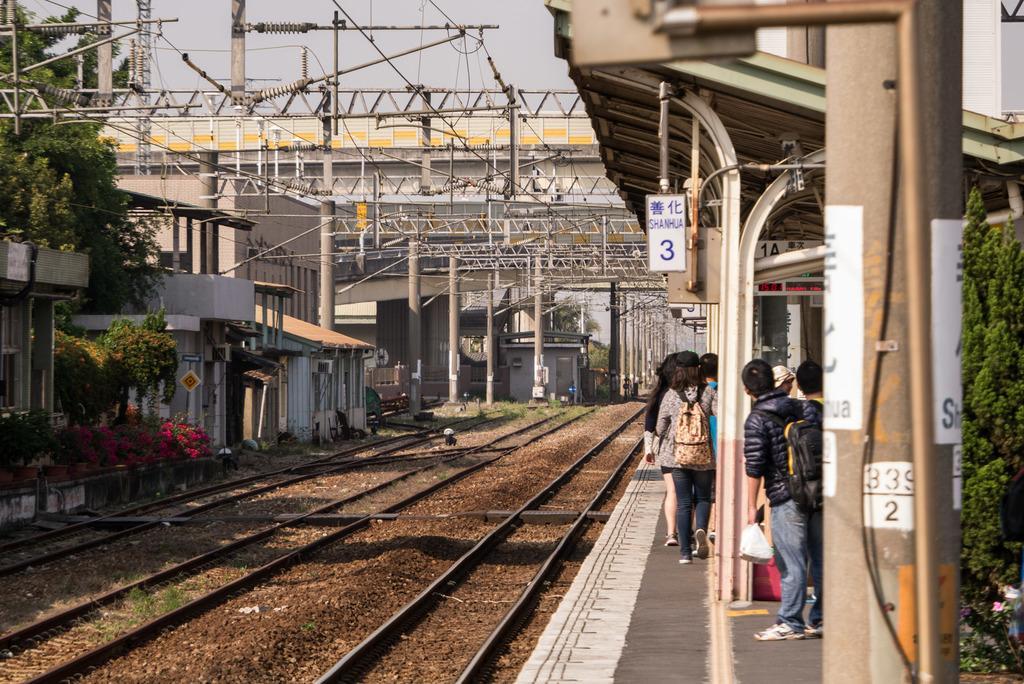In one or two sentences, can you explain what this image depicts? In this image we can see a railway track, here are the group of persons standing, here is the pole, here are the trees, here are the flowers, at above here is the sky. 